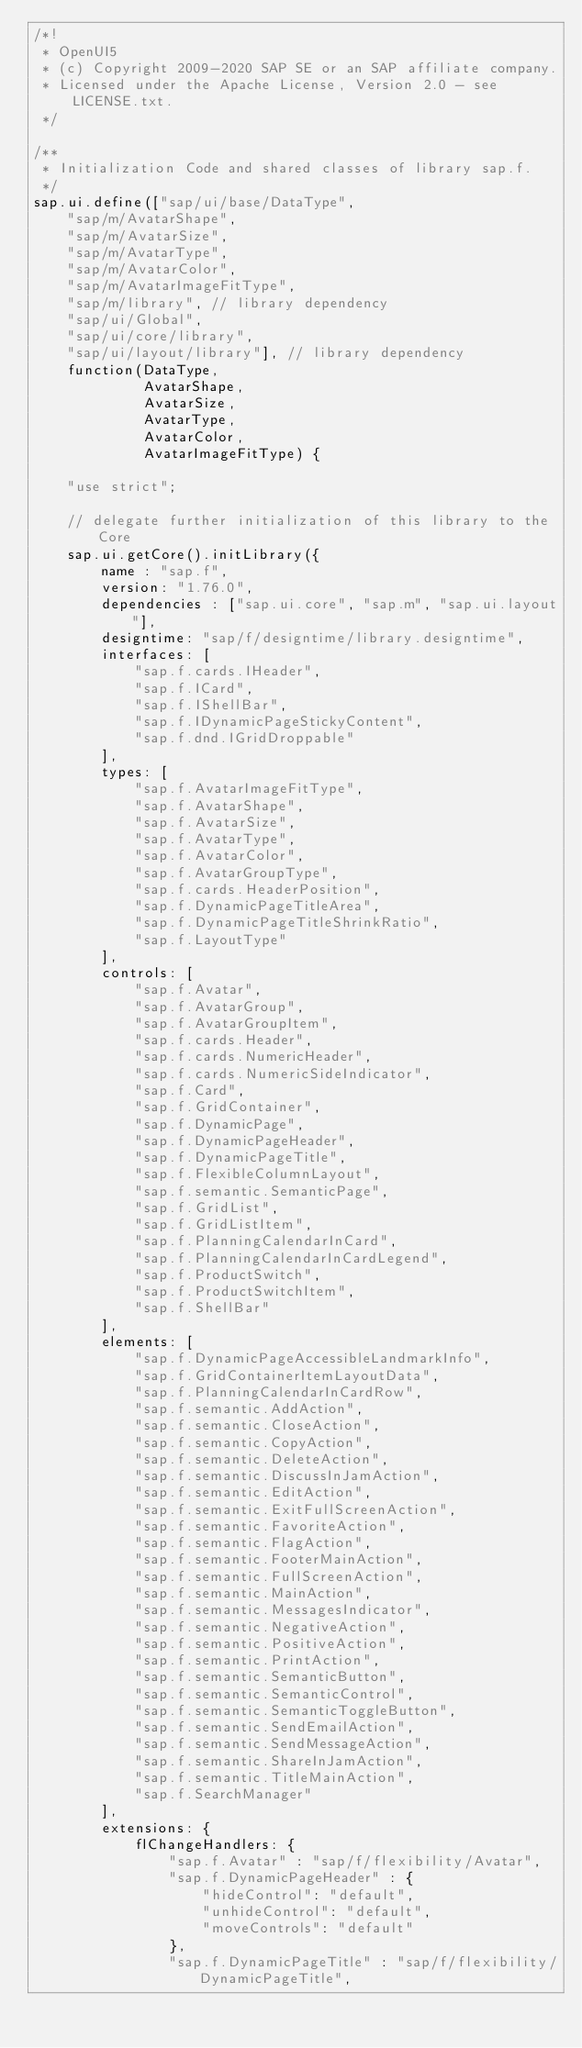Convert code to text. <code><loc_0><loc_0><loc_500><loc_500><_JavaScript_>/*!
 * OpenUI5
 * (c) Copyright 2009-2020 SAP SE or an SAP affiliate company.
 * Licensed under the Apache License, Version 2.0 - see LICENSE.txt.
 */

/**
 * Initialization Code and shared classes of library sap.f.
 */
sap.ui.define(["sap/ui/base/DataType",
	"sap/m/AvatarShape",
	"sap/m/AvatarSize",
	"sap/m/AvatarType",
	"sap/m/AvatarColor",
	"sap/m/AvatarImageFitType",
	"sap/m/library", // library dependency
	"sap/ui/Global",
	"sap/ui/core/library",
	"sap/ui/layout/library"], // library dependency
	function(DataType,
			 AvatarShape,
			 AvatarSize,
			 AvatarType,
			 AvatarColor,
			 AvatarImageFitType) {

	"use strict";

	// delegate further initialization of this library to the Core
	sap.ui.getCore().initLibrary({
		name : "sap.f",
		version: "1.76.0",
		dependencies : ["sap.ui.core", "sap.m", "sap.ui.layout"],
		designtime: "sap/f/designtime/library.designtime",
		interfaces: [
			"sap.f.cards.IHeader",
			"sap.f.ICard",
			"sap.f.IShellBar",
			"sap.f.IDynamicPageStickyContent",
			"sap.f.dnd.IGridDroppable"
		],
		types: [
			"sap.f.AvatarImageFitType",
			"sap.f.AvatarShape",
			"sap.f.AvatarSize",
			"sap.f.AvatarType",
			"sap.f.AvatarColor",
			"sap.f.AvatarGroupType",
			"sap.f.cards.HeaderPosition",
			"sap.f.DynamicPageTitleArea",
			"sap.f.DynamicPageTitleShrinkRatio",
			"sap.f.LayoutType"
		],
		controls: [
			"sap.f.Avatar",
			"sap.f.AvatarGroup",
			"sap.f.AvatarGroupItem",
			"sap.f.cards.Header",
			"sap.f.cards.NumericHeader",
			"sap.f.cards.NumericSideIndicator",
			"sap.f.Card",
			"sap.f.GridContainer",
			"sap.f.DynamicPage",
			"sap.f.DynamicPageHeader",
			"sap.f.DynamicPageTitle",
			"sap.f.FlexibleColumnLayout",
			"sap.f.semantic.SemanticPage",
			"sap.f.GridList",
			"sap.f.GridListItem",
			"sap.f.PlanningCalendarInCard",
			"sap.f.PlanningCalendarInCardLegend",
			"sap.f.ProductSwitch",
			"sap.f.ProductSwitchItem",
			"sap.f.ShellBar"
		],
		elements: [
			"sap.f.DynamicPageAccessibleLandmarkInfo",
			"sap.f.GridContainerItemLayoutData",
			"sap.f.PlanningCalendarInCardRow",
			"sap.f.semantic.AddAction",
			"sap.f.semantic.CloseAction",
			"sap.f.semantic.CopyAction",
			"sap.f.semantic.DeleteAction",
			"sap.f.semantic.DiscussInJamAction",
			"sap.f.semantic.EditAction",
			"sap.f.semantic.ExitFullScreenAction",
			"sap.f.semantic.FavoriteAction",
			"sap.f.semantic.FlagAction",
			"sap.f.semantic.FooterMainAction",
			"sap.f.semantic.FullScreenAction",
			"sap.f.semantic.MainAction",
			"sap.f.semantic.MessagesIndicator",
			"sap.f.semantic.NegativeAction",
			"sap.f.semantic.PositiveAction",
			"sap.f.semantic.PrintAction",
			"sap.f.semantic.SemanticButton",
			"sap.f.semantic.SemanticControl",
			"sap.f.semantic.SemanticToggleButton",
			"sap.f.semantic.SendEmailAction",
			"sap.f.semantic.SendMessageAction",
			"sap.f.semantic.ShareInJamAction",
			"sap.f.semantic.TitleMainAction",
			"sap.f.SearchManager"
		],
		extensions: {
			flChangeHandlers: {
				"sap.f.Avatar" : "sap/f/flexibility/Avatar",
				"sap.f.DynamicPageHeader" : {
					"hideControl": "default",
					"unhideControl": "default",
					"moveControls": "default"
				},
				"sap.f.DynamicPageTitle" : "sap/f/flexibility/DynamicPageTitle",</code> 